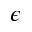<formula> <loc_0><loc_0><loc_500><loc_500>\epsilon</formula> 